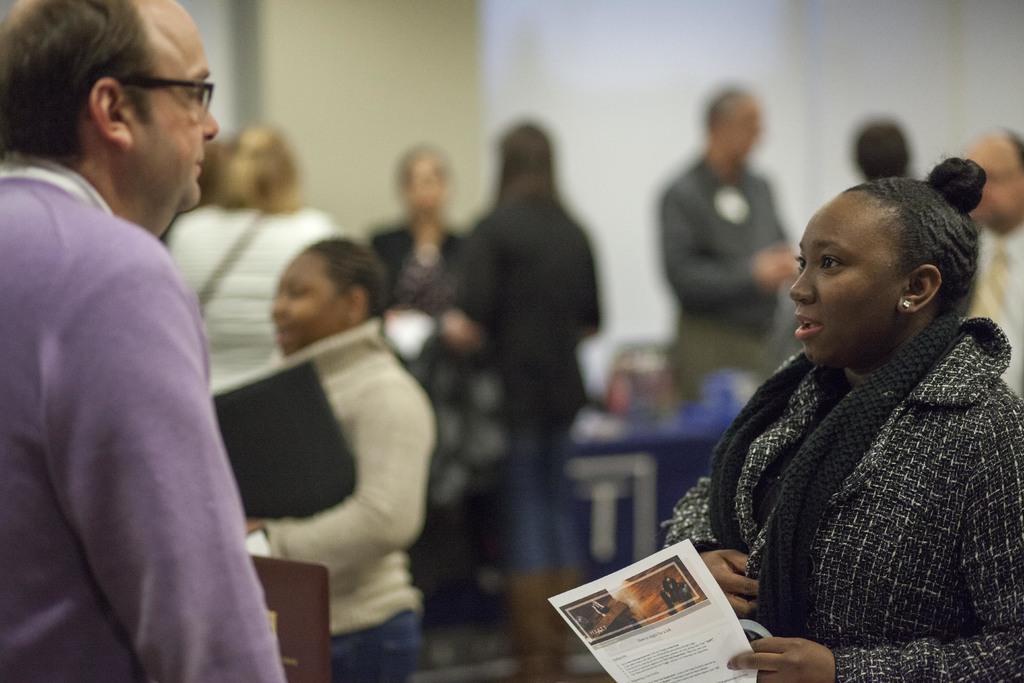Can you describe this image briefly? In the image there are many people gathered in an area and in the front a woman and a man are standing and talking to each other,the woman is wearing black dress and she is holding a paper in her hand and except the two people the remaining people pictures are blurred. 